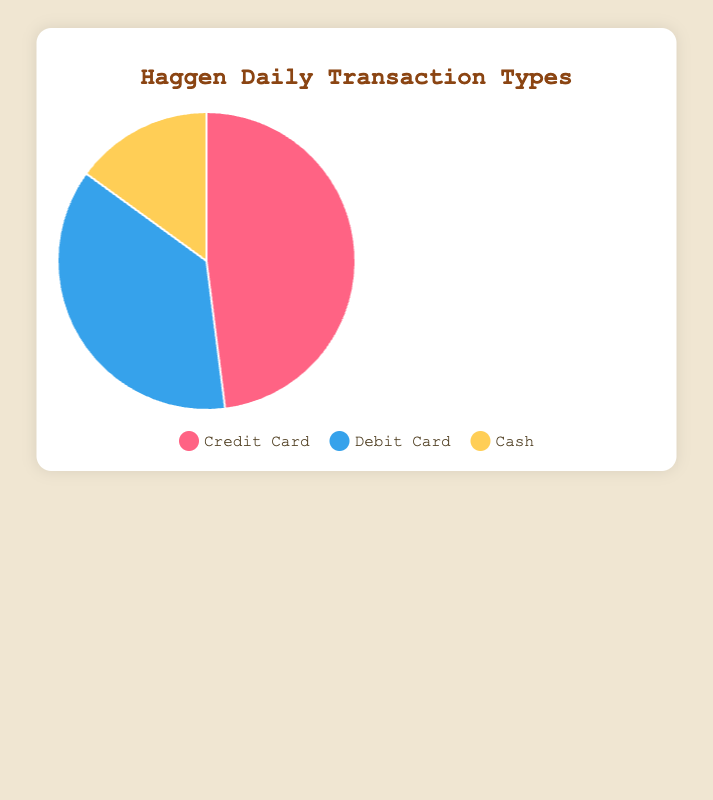What's the percentage of transactions made with Debit Cards? Refer to the figure which shows the distribution of transaction types. The part of the pie chart labeled "Debit Card" occupies 37%.
Answer: 37% Which type of transaction is the least common? Look at the pie chart and identify the smallest slice. The "Cash" slice is the smallest, indicating it is the least common.
Answer: Cash Are Credit Card transactions more common than Cash and Debit Card transactions combined? Compare the sum of the percentages for Cash and Debit Card transactions to that of Credit Card transactions. Cash (15%) + Debit Card (37%) = 52%, which is greater than the 48% for Credit Card transactions.
Answer: No What is the ratio of Credit Card to Debit Card transactions? Divide the percentage of Credit Card transactions by that of Debit Card transactions. 48% / 37% = approximately 1.3.
Answer: About 1.3 How much more popular are Credit Card transactions than Cash transactions by percentage? Subtract the percentage of Cash transactions from the percentage of Credit Card transactions. 48% - 15% = 33%.
Answer: 33% Which color represents Cash transactions in the pie chart? Look at the legend below the chart, which maps transaction types to colors. The color corresponding to "Cash" is yellow.
Answer: Yellow What percentage of transactions are made with either Credit Cards or Cash? Combine the percentages of Credit Card and Cash transactions. 48% (Credit Card) + 15% (Cash) = 63%.
Answer: 63% Which transaction type has a blue color in the chart? Refer to the legend that denotes which color is associated with which transaction type. The color blue is mapped to Debit Card.
Answer: Debit Card If there were 1000 transactions in a day, how many of those would be done using Debit Cards? Calculate 37% of 1000 transactions. (37/100) * 1000 = 370 transactions.
Answer: 370 What's the difference in percentage between the highest and the lowest transaction types? Determine the difference between the highest percentage (Credit Card: 48%) and the lowest (Cash: 15%). 48% - 15% = 33%.
Answer: 33% 